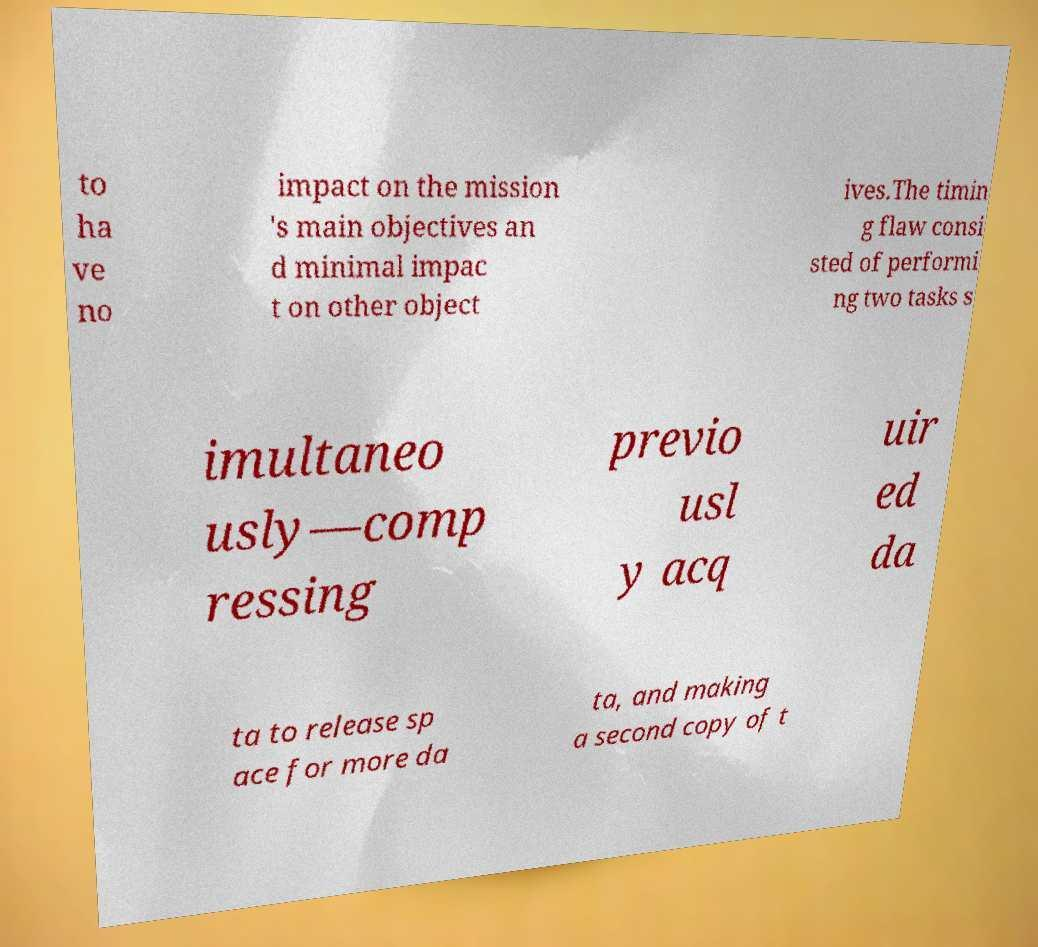What messages or text are displayed in this image? I need them in a readable, typed format. to ha ve no impact on the mission 's main objectives an d minimal impac t on other object ives.The timin g flaw consi sted of performi ng two tasks s imultaneo usly—comp ressing previo usl y acq uir ed da ta to release sp ace for more da ta, and making a second copy of t 